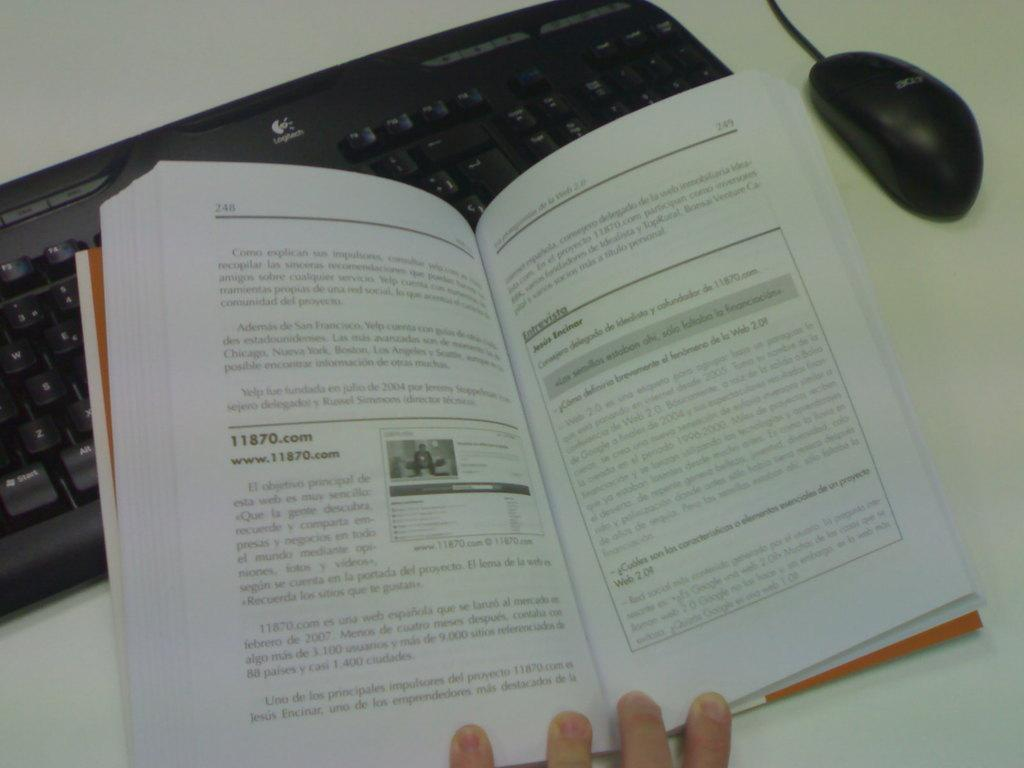Provide a one-sentence caption for the provided image. On page 248 of this book you can find the text www.11870.com. 